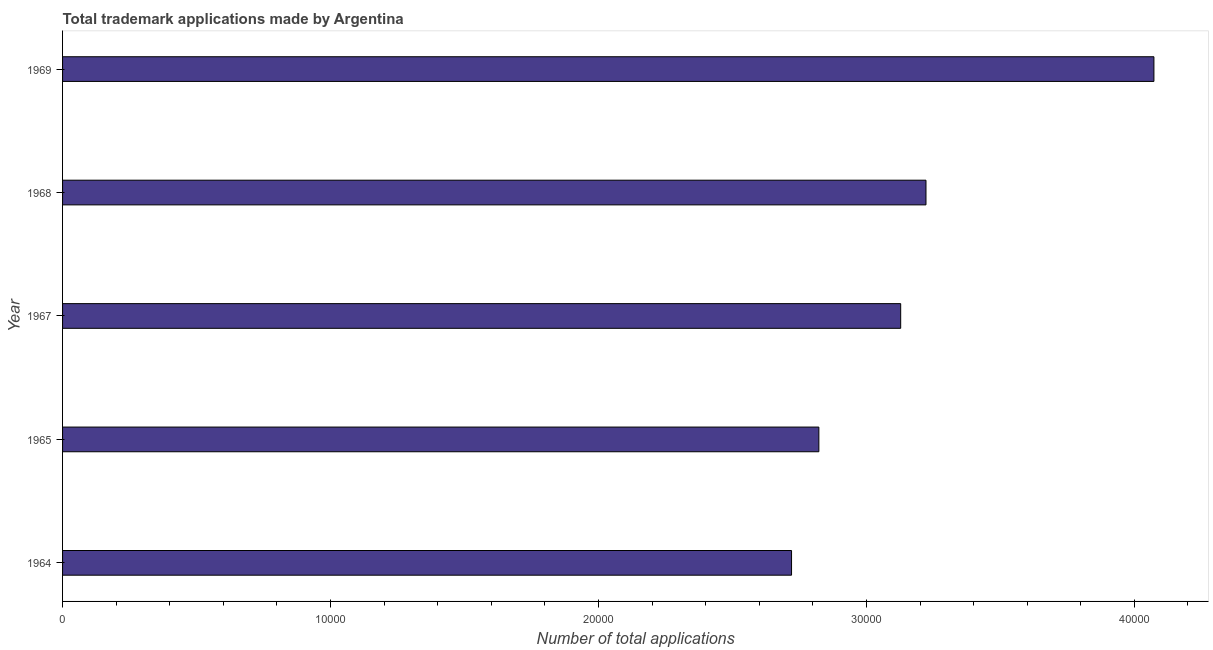What is the title of the graph?
Make the answer very short. Total trademark applications made by Argentina. What is the label or title of the X-axis?
Keep it short and to the point. Number of total applications. What is the label or title of the Y-axis?
Your answer should be compact. Year. What is the number of trademark applications in 1965?
Your response must be concise. 2.82e+04. Across all years, what is the maximum number of trademark applications?
Ensure brevity in your answer.  4.07e+04. Across all years, what is the minimum number of trademark applications?
Ensure brevity in your answer.  2.72e+04. In which year was the number of trademark applications maximum?
Provide a short and direct response. 1969. In which year was the number of trademark applications minimum?
Provide a short and direct response. 1964. What is the sum of the number of trademark applications?
Offer a very short reply. 1.60e+05. What is the difference between the number of trademark applications in 1968 and 1969?
Provide a short and direct response. -8507. What is the average number of trademark applications per year?
Keep it short and to the point. 3.19e+04. What is the median number of trademark applications?
Keep it short and to the point. 3.13e+04. In how many years, is the number of trademark applications greater than 2000 ?
Ensure brevity in your answer.  5. Do a majority of the years between 1965 and 1968 (inclusive) have number of trademark applications greater than 18000 ?
Your response must be concise. Yes. What is the ratio of the number of trademark applications in 1965 to that in 1967?
Provide a short and direct response. 0.9. Is the number of trademark applications in 1967 less than that in 1968?
Provide a succinct answer. Yes. Is the difference between the number of trademark applications in 1965 and 1969 greater than the difference between any two years?
Make the answer very short. No. What is the difference between the highest and the second highest number of trademark applications?
Provide a short and direct response. 8507. Is the sum of the number of trademark applications in 1967 and 1969 greater than the maximum number of trademark applications across all years?
Your answer should be compact. Yes. What is the difference between the highest and the lowest number of trademark applications?
Make the answer very short. 1.35e+04. In how many years, is the number of trademark applications greater than the average number of trademark applications taken over all years?
Provide a succinct answer. 2. Are all the bars in the graph horizontal?
Offer a terse response. Yes. How many years are there in the graph?
Keep it short and to the point. 5. What is the Number of total applications in 1964?
Offer a very short reply. 2.72e+04. What is the Number of total applications in 1965?
Offer a very short reply. 2.82e+04. What is the Number of total applications in 1967?
Ensure brevity in your answer.  3.13e+04. What is the Number of total applications in 1968?
Your answer should be compact. 3.22e+04. What is the Number of total applications of 1969?
Make the answer very short. 4.07e+04. What is the difference between the Number of total applications in 1964 and 1965?
Make the answer very short. -1019. What is the difference between the Number of total applications in 1964 and 1967?
Make the answer very short. -4073. What is the difference between the Number of total applications in 1964 and 1968?
Provide a short and direct response. -5017. What is the difference between the Number of total applications in 1964 and 1969?
Keep it short and to the point. -1.35e+04. What is the difference between the Number of total applications in 1965 and 1967?
Provide a short and direct response. -3054. What is the difference between the Number of total applications in 1965 and 1968?
Offer a terse response. -3998. What is the difference between the Number of total applications in 1965 and 1969?
Give a very brief answer. -1.25e+04. What is the difference between the Number of total applications in 1967 and 1968?
Your answer should be very brief. -944. What is the difference between the Number of total applications in 1967 and 1969?
Make the answer very short. -9451. What is the difference between the Number of total applications in 1968 and 1969?
Make the answer very short. -8507. What is the ratio of the Number of total applications in 1964 to that in 1967?
Give a very brief answer. 0.87. What is the ratio of the Number of total applications in 1964 to that in 1968?
Your response must be concise. 0.84. What is the ratio of the Number of total applications in 1964 to that in 1969?
Ensure brevity in your answer.  0.67. What is the ratio of the Number of total applications in 1965 to that in 1967?
Offer a very short reply. 0.9. What is the ratio of the Number of total applications in 1965 to that in 1968?
Make the answer very short. 0.88. What is the ratio of the Number of total applications in 1965 to that in 1969?
Ensure brevity in your answer.  0.69. What is the ratio of the Number of total applications in 1967 to that in 1968?
Offer a terse response. 0.97. What is the ratio of the Number of total applications in 1967 to that in 1969?
Offer a terse response. 0.77. What is the ratio of the Number of total applications in 1968 to that in 1969?
Your answer should be very brief. 0.79. 